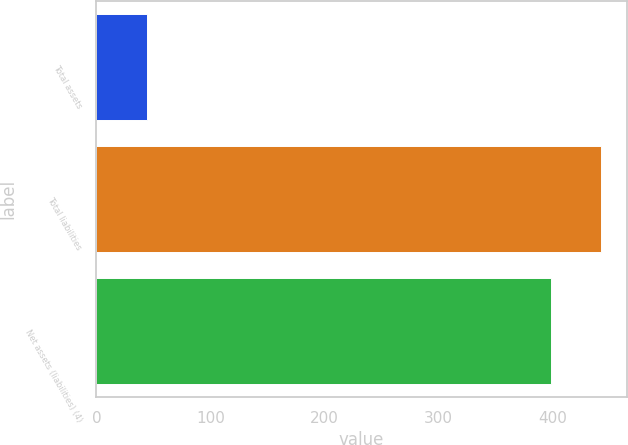Convert chart. <chart><loc_0><loc_0><loc_500><loc_500><bar_chart><fcel>Total assets<fcel>Total liabilities<fcel>Net assets (liabilities) (4)<nl><fcel>44<fcel>443<fcel>399<nl></chart> 